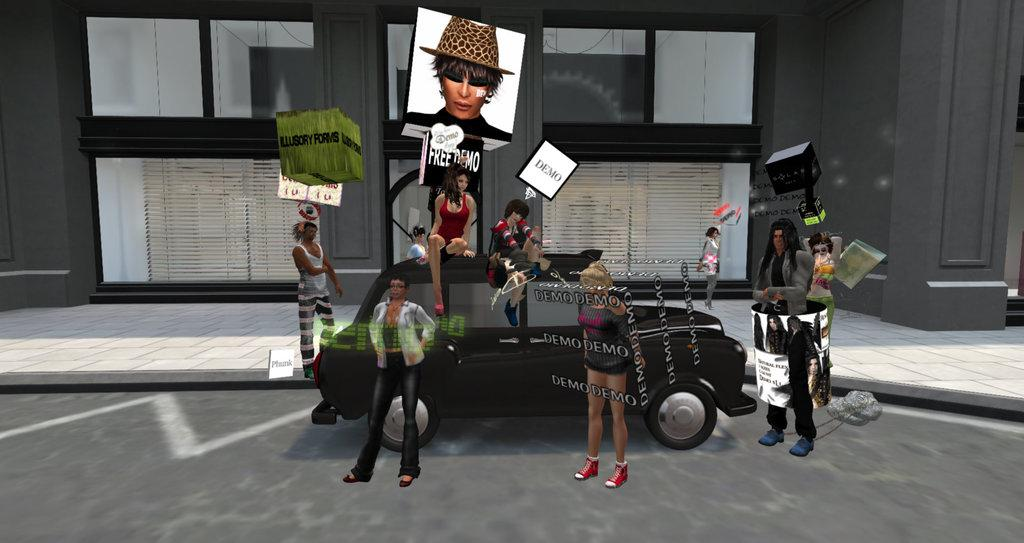What is present in the image? There are people in the image. What are the people doing in the image? The people are standing and sitting on a vehicle. What type of produce can be seen growing in the image? There is no produce present in the image; it features people standing and sitting on a vehicle. What channel might be broadcasting the scene in the image? The image does not depict a scene being broadcasted on a channel; it simply shows people on a vehicle. 